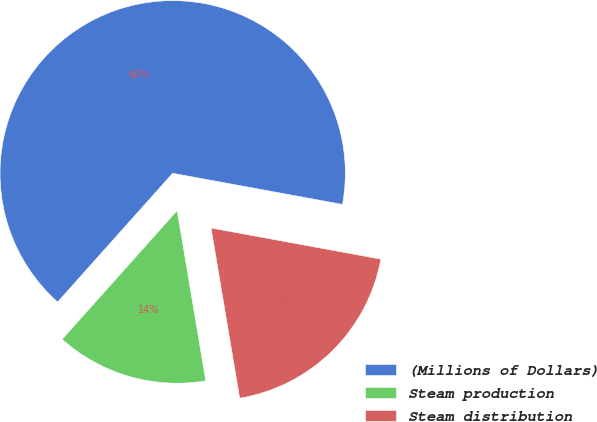Convert chart to OTSL. <chart><loc_0><loc_0><loc_500><loc_500><pie_chart><fcel>(Millions of Dollars)<fcel>Steam production<fcel>Steam distribution<nl><fcel>66.28%<fcel>14.26%<fcel>19.46%<nl></chart> 